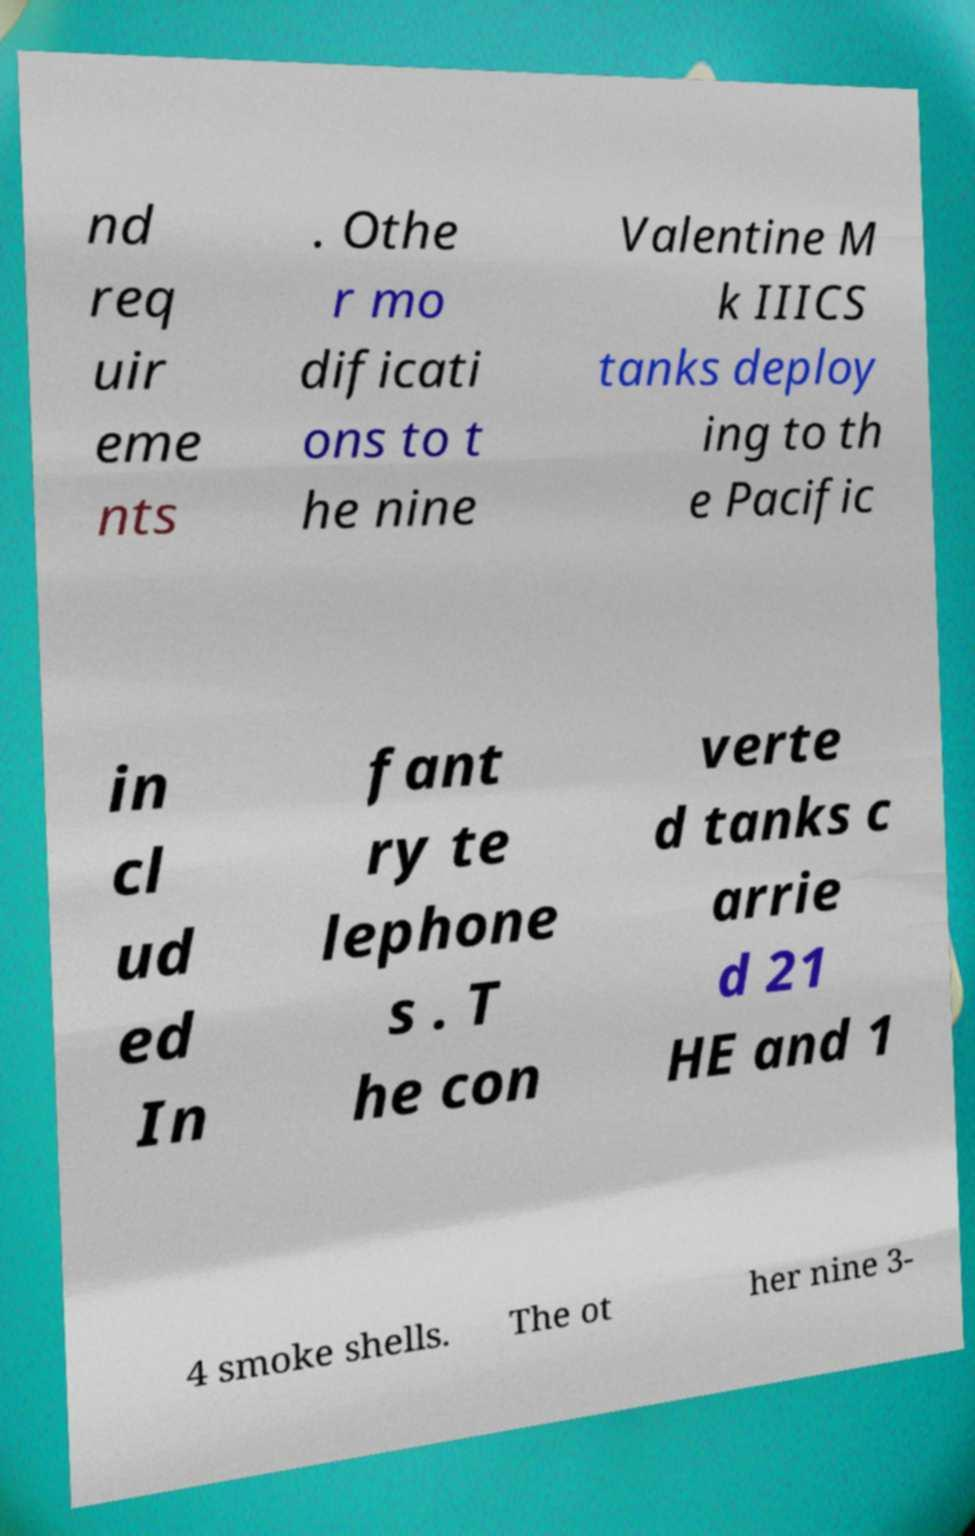Could you extract and type out the text from this image? nd req uir eme nts . Othe r mo dificati ons to t he nine Valentine M k IIICS tanks deploy ing to th e Pacific in cl ud ed In fant ry te lephone s . T he con verte d tanks c arrie d 21 HE and 1 4 smoke shells. The ot her nine 3- 